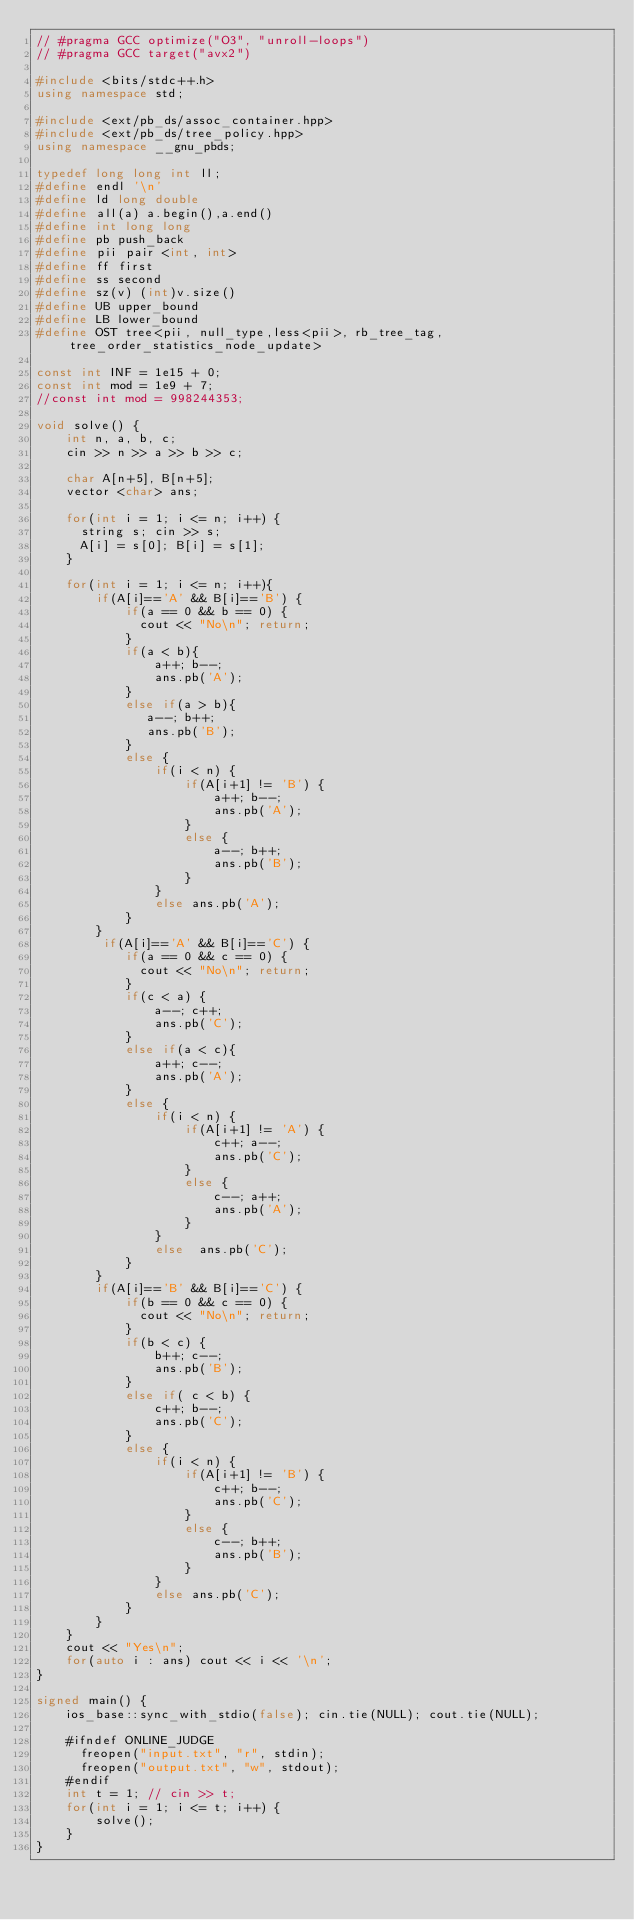<code> <loc_0><loc_0><loc_500><loc_500><_C++_>// #pragma GCC optimize("O3", "unroll-loops")
// #pragma GCC target("avx2")

#include <bits/stdc++.h>
using namespace std;

#include <ext/pb_ds/assoc_container.hpp> 
#include <ext/pb_ds/tree_policy.hpp> 
using namespace __gnu_pbds;

typedef long long int ll;
#define endl '\n'
#define ld long double
#define all(a) a.begin(),a.end()
#define int long long
#define pb push_back
#define pii pair <int, int>
#define ff first
#define ss second
#define sz(v) (int)v.size() 
#define UB upper_bound
#define LB lower_bound
#define OST tree<pii, null_type,less<pii>, rb_tree_tag,tree_order_statistics_node_update>

const int INF = 1e15 + 0;
const int mod = 1e9 + 7;
//const int mod = 998244353;

void solve() {
    int n, a, b, c;
    cin >> n >> a >> b >> c;
    
    char A[n+5], B[n+5];
    vector <char> ans;

    for(int i = 1; i <= n; i++) {
      string s; cin >> s;
      A[i] = s[0]; B[i] = s[1];
    }
    
    for(int i = 1; i <= n; i++){
        if(A[i]=='A' && B[i]=='B') {
            if(a == 0 && b == 0) {
              cout << "No\n"; return;
            }
            if(a < b){
                a++; b--;
                ans.pb('A');
            }
            else if(a > b){
               a--; b++;
               ans.pb('B');
            }
            else {
                if(i < n) {
                    if(A[i+1] != 'B') {
                        a++; b--;
                        ans.pb('A');
                    }
                    else {
                        a--; b++;
                        ans.pb('B');
                    }
                }
                else ans.pb('A');
            }
        }
         if(A[i]=='A' && B[i]=='C') {
            if(a == 0 && c == 0) {
              cout << "No\n"; return;
            }
            if(c < a) {
                a--; c++;
                ans.pb('C');
            }
            else if(a < c){
                a++; c--;
                ans.pb('A');
            }
            else {
                if(i < n) {
                    if(A[i+1] != 'A') {
                        c++; a--;
                        ans.pb('C');
                    }
                    else {
                        c--; a++;
                        ans.pb('A');
                    }
                }
                else  ans.pb('C');
            }
        }
        if(A[i]=='B' && B[i]=='C') {
            if(b == 0 && c == 0) {
              cout << "No\n"; return;
            }
            if(b < c) {
                b++; c--;
                ans.pb('B');
            }
            else if( c < b) {
                c++; b--;
                ans.pb('C');
            }
            else {
                if(i < n) {
                    if(A[i+1] != 'B') {
                        c++; b--;
                        ans.pb('C');
                    }
                    else {
                        c--; b++;
                        ans.pb('B');
                    }
                }
                else ans.pb('C');
            }
        }
    }
    cout << "Yes\n";
    for(auto i : ans) cout << i << '\n';
}   

signed main() {
    ios_base::sync_with_stdio(false); cin.tie(NULL); cout.tie(NULL);

    #ifndef ONLINE_JUDGE
      freopen("input.txt", "r", stdin);
      freopen("output.txt", "w", stdout);
    #endif
    int t = 1; // cin >> t;
    for(int i = 1; i <= t; i++) {
        solve();
    }
}    
</code> 